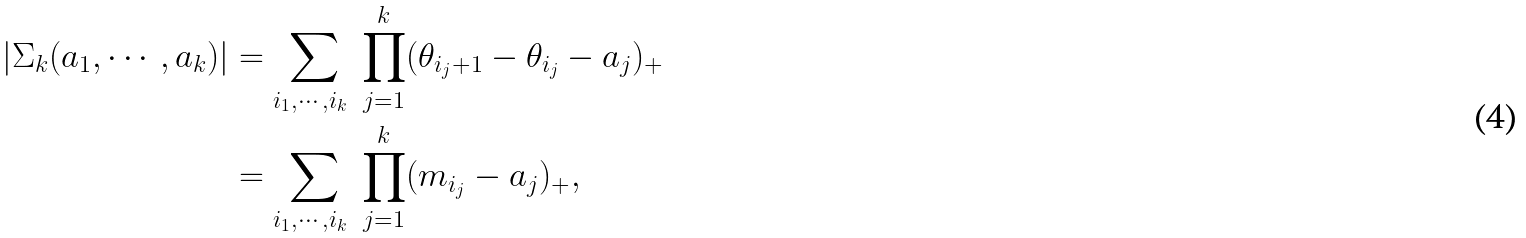Convert formula to latex. <formula><loc_0><loc_0><loc_500><loc_500>| \Sigma _ { k } ( a _ { 1 } , \cdots , a _ { k } ) | & = \sum _ { i _ { 1 } , \cdots , i _ { k } \ } \prod _ { j = 1 } ^ { k } ( \theta _ { i _ { j } + 1 } - \theta _ { i _ { j } } - a _ { j } ) _ { + } \\ & = \sum _ { i _ { 1 } , \cdots , i _ { k } \ } \prod _ { j = 1 } ^ { k } ( m _ { i _ { j } } - a _ { j } ) _ { + } ,</formula> 